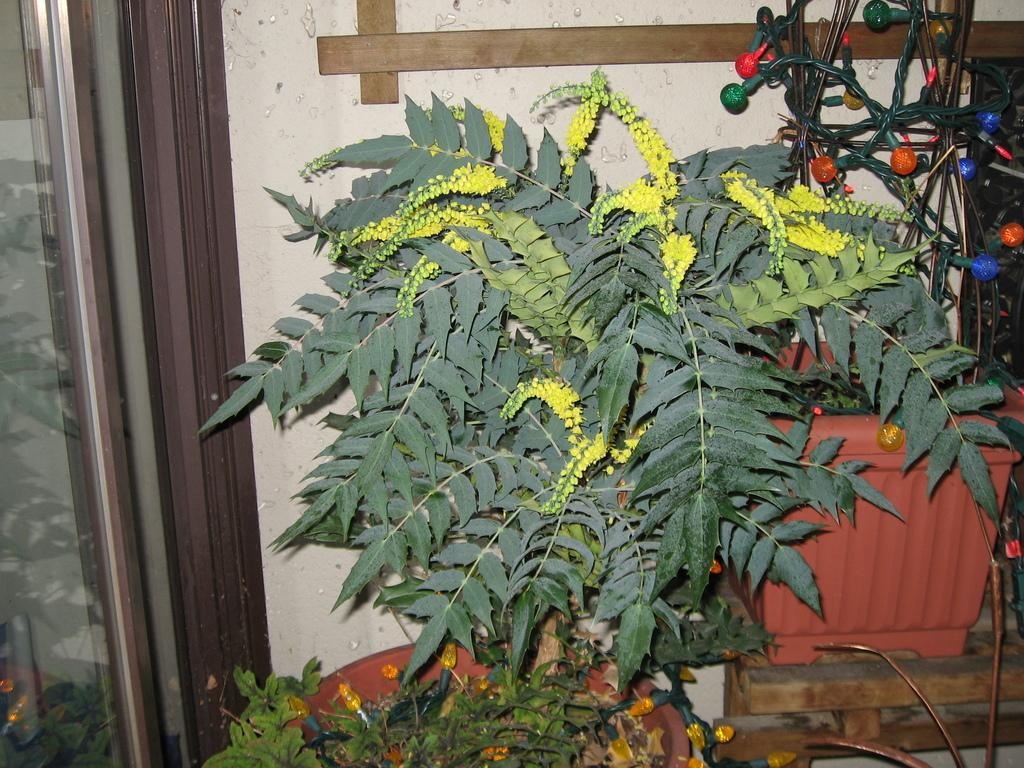What is located in the middle of the image? There are plants in the middle of the image. What can be seen behind the plants? There is a wall behind the plants. What type of sack can be seen hanging from the plants in the image? There is no sack present in the image; it only features plants and a wall. What color is the thread used to tie the plants together in the image? There is no thread or tying of plants visible in the image. 